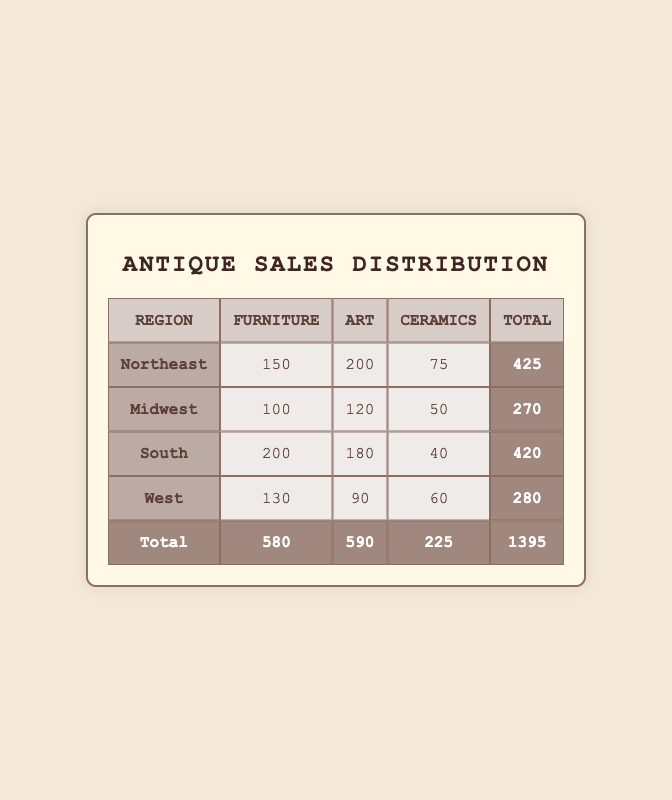What region has the highest total sales? The Northeast region has the highest total sales of 425 when we look at the totals in the last column of the table.
Answer: Northeast How many sales of Ceramics were made in the South? The row for the South indicates that there were 40 sales of Ceramics, as shown in the table.
Answer: 40 What is the total sales for the Midwest? The total sales for the Midwest is found in the last column of the Midwest row, which indicates a total of 270 sales.
Answer: 270 Which antique type had the least sales overall? By comparing the total sales for each antique type in the last row, we see that Ceramics had the least overall sales, with a total of 225.
Answer: Ceramics Is the total sales in the South greater than the combined total of the West and Midwest? The South has a total of 420, while the Midwest has 270 and the West has 280. Adding the two gives (270 + 280 = 550), which is greater than 420. Therefore, the statement is false.
Answer: No What is the average sales of Furniture across all regions? To find the average, we sum the sales of Furniture: (150 + 100 + 200 + 130) = 580. There are four regions, so we divide: 580 / 4 = 145.
Answer: 145 What percentage of the total sales is attributed to Art in the Northeast? The total sales in the Northeast is 425, with 200 sales attributed to Art. The percentage is calculated as (200 / 425) * 100 = 47.06.
Answer: 47.06 Which region has the most sales of Art? Looking at the Art sales in the table, the Northeast had the highest with 200 sales, making it the region with the most Art sales.
Answer: Northeast What is the difference in total sales between the South and the West? The total sales for the South is 420, while the West is 280. The difference is 420 - 280 = 140.
Answer: 140 